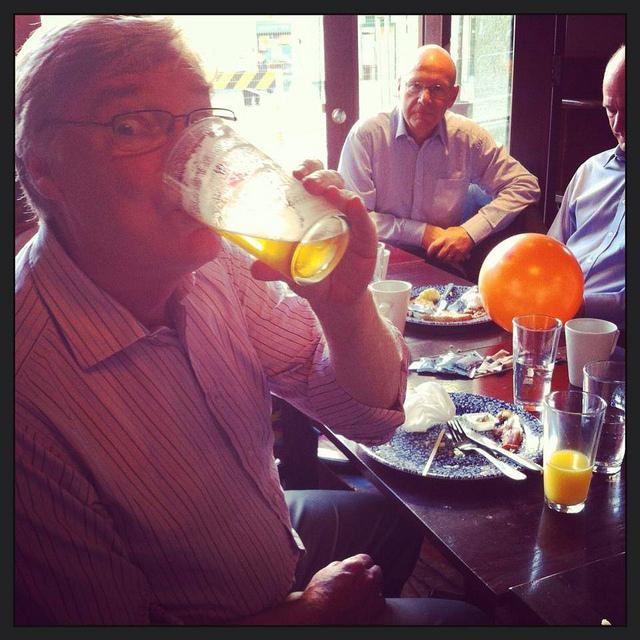What drug is this man ingesting? Please explain your reasoning. alcohol. The drink is golden and transparent. 